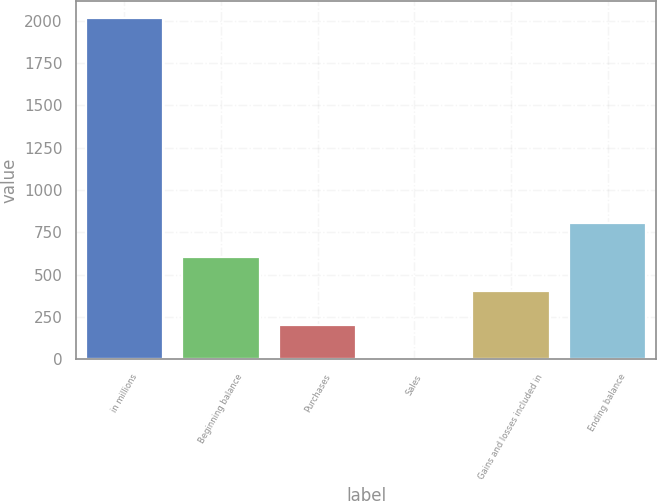Convert chart to OTSL. <chart><loc_0><loc_0><loc_500><loc_500><bar_chart><fcel>in millions<fcel>Beginning balance<fcel>Purchases<fcel>Sales<fcel>Gains and losses included in<fcel>Ending balance<nl><fcel>2015<fcel>606.46<fcel>204.02<fcel>2.8<fcel>405.24<fcel>807.68<nl></chart> 